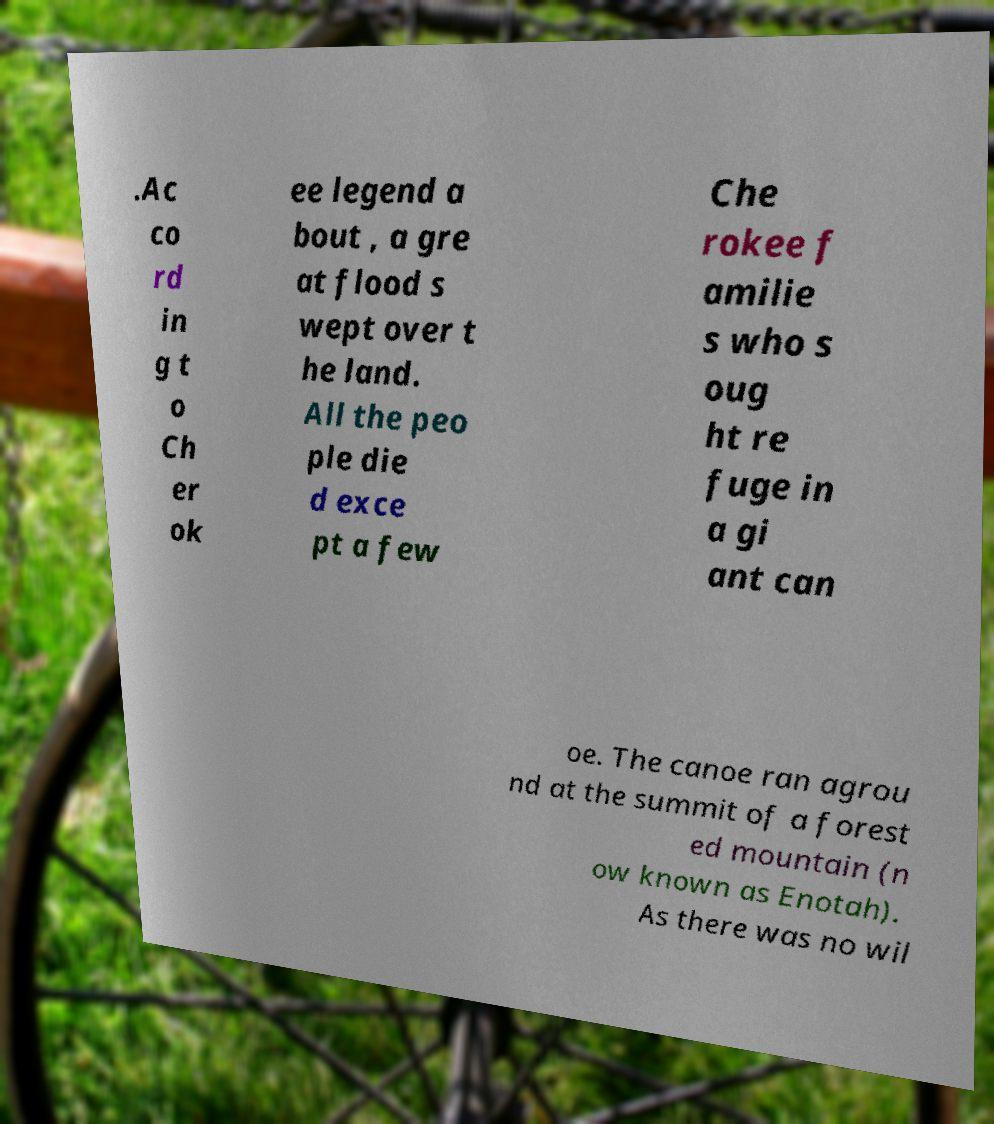Please identify and transcribe the text found in this image. .Ac co rd in g t o Ch er ok ee legend a bout , a gre at flood s wept over t he land. All the peo ple die d exce pt a few Che rokee f amilie s who s oug ht re fuge in a gi ant can oe. The canoe ran agrou nd at the summit of a forest ed mountain (n ow known as Enotah). As there was no wil 